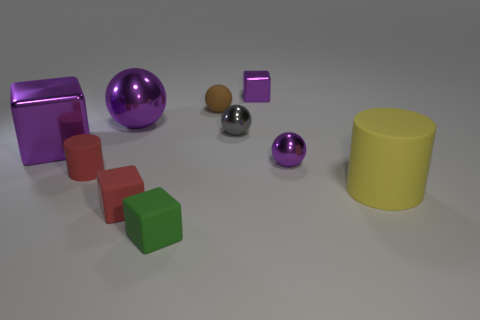Subtract all large purple metallic balls. How many balls are left? 3 Subtract all brown balls. How many balls are left? 3 Subtract 2 spheres. How many spheres are left? 2 Subtract 0 brown cylinders. How many objects are left? 10 Subtract all cylinders. How many objects are left? 8 Subtract all yellow cylinders. Subtract all red spheres. How many cylinders are left? 1 Subtract all green cylinders. How many yellow blocks are left? 0 Subtract all large cyan metallic spheres. Subtract all gray balls. How many objects are left? 9 Add 5 brown things. How many brown things are left? 6 Add 9 tiny brown rubber things. How many tiny brown rubber things exist? 10 